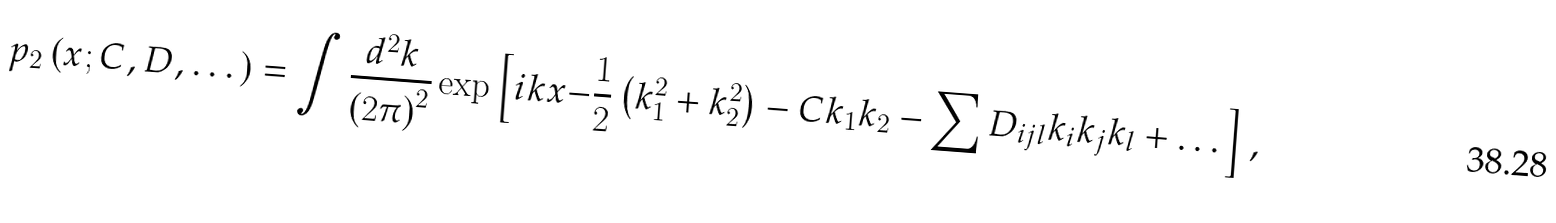Convert formula to latex. <formula><loc_0><loc_0><loc_500><loc_500>p _ { 2 } \left ( { x } ; C , D , \dots \right ) = \int \frac { d ^ { 2 } { k } } { \left ( 2 \pi \right ) ^ { 2 } } \exp \left [ i { k x - } \frac { 1 } { 2 } \left ( k _ { 1 } ^ { 2 } + k _ { 2 } ^ { 2 } \right ) - C k _ { 1 } k _ { 2 } - \sum D _ { i j l } k _ { i } k _ { j } k _ { l } + \dots \right ] ,</formula> 